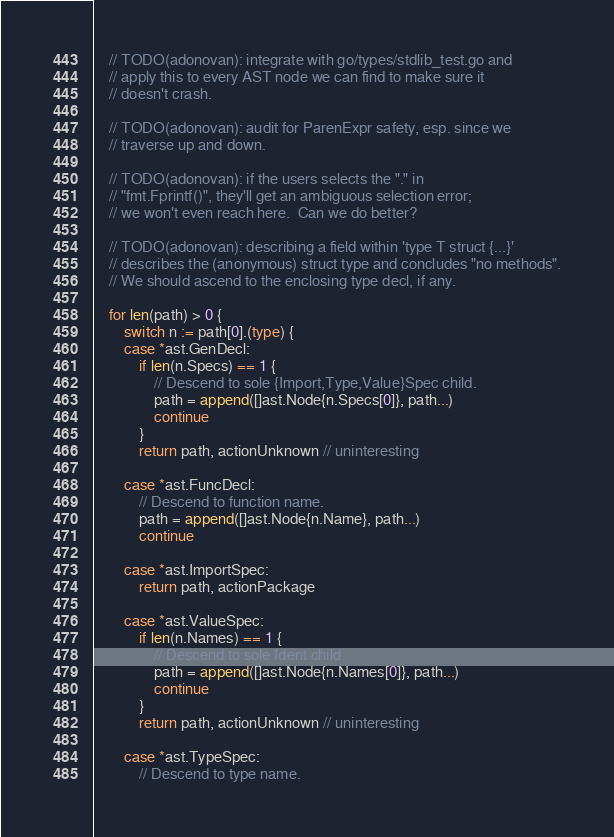<code> <loc_0><loc_0><loc_500><loc_500><_Go_>	// TODO(adonovan): integrate with go/types/stdlib_test.go and
	// apply this to every AST node we can find to make sure it
	// doesn't crash.

	// TODO(adonovan): audit for ParenExpr safety, esp. since we
	// traverse up and down.

	// TODO(adonovan): if the users selects the "." in
	// "fmt.Fprintf()", they'll get an ambiguous selection error;
	// we won't even reach here.  Can we do better?

	// TODO(adonovan): describing a field within 'type T struct {...}'
	// describes the (anonymous) struct type and concludes "no methods".
	// We should ascend to the enclosing type decl, if any.

	for len(path) > 0 {
		switch n := path[0].(type) {
		case *ast.GenDecl:
			if len(n.Specs) == 1 {
				// Descend to sole {Import,Type,Value}Spec child.
				path = append([]ast.Node{n.Specs[0]}, path...)
				continue
			}
			return path, actionUnknown // uninteresting

		case *ast.FuncDecl:
			// Descend to function name.
			path = append([]ast.Node{n.Name}, path...)
			continue

		case *ast.ImportSpec:
			return path, actionPackage

		case *ast.ValueSpec:
			if len(n.Names) == 1 {
				// Descend to sole Ident child.
				path = append([]ast.Node{n.Names[0]}, path...)
				continue
			}
			return path, actionUnknown // uninteresting

		case *ast.TypeSpec:
			// Descend to type name.</code> 